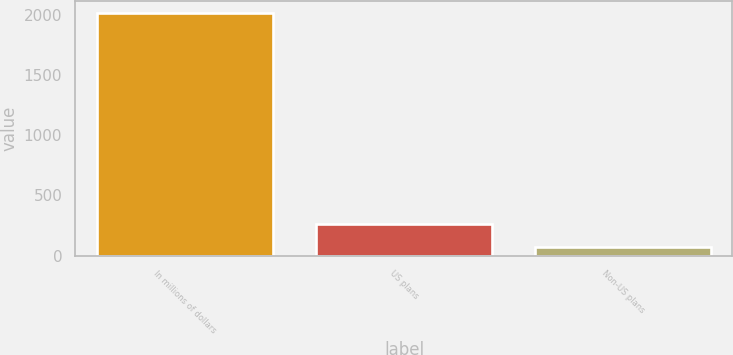Convert chart. <chart><loc_0><loc_0><loc_500><loc_500><bar_chart><fcel>In millions of dollars<fcel>US plans<fcel>Non-US plans<nl><fcel>2013<fcel>262.5<fcel>68<nl></chart> 